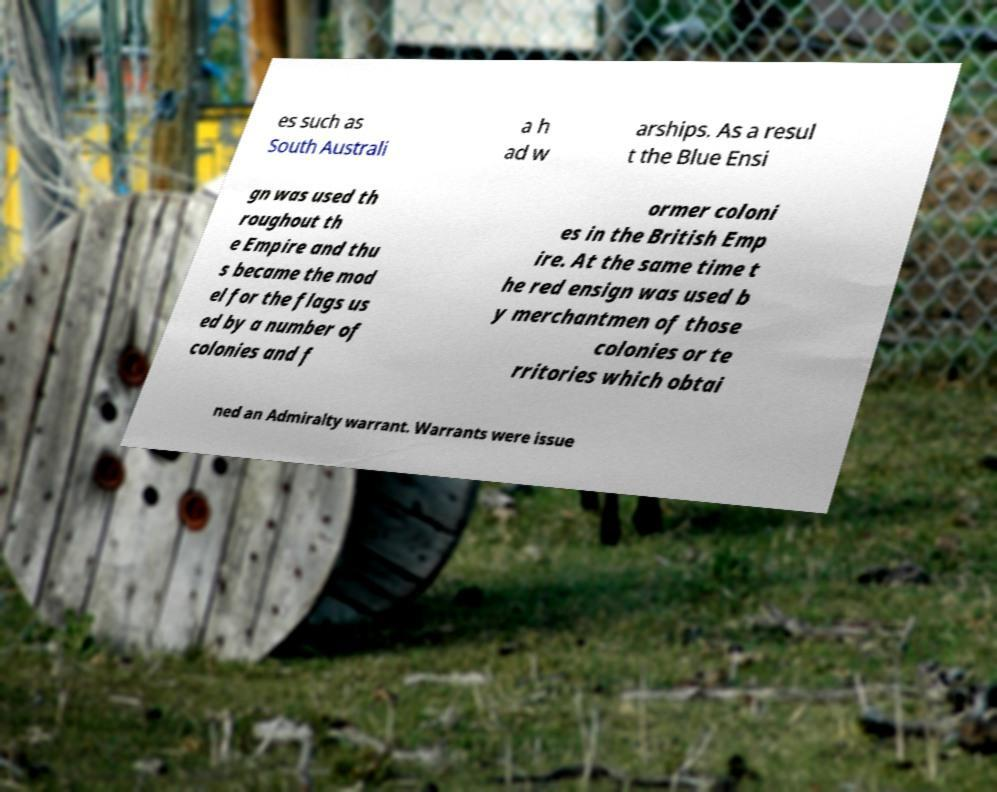For documentation purposes, I need the text within this image transcribed. Could you provide that? es such as South Australi a h ad w arships. As a resul t the Blue Ensi gn was used th roughout th e Empire and thu s became the mod el for the flags us ed by a number of colonies and f ormer coloni es in the British Emp ire. At the same time t he red ensign was used b y merchantmen of those colonies or te rritories which obtai ned an Admiralty warrant. Warrants were issue 